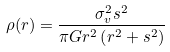Convert formula to latex. <formula><loc_0><loc_0><loc_500><loc_500>\rho ( r ) = \frac { \sigma _ { v } ^ { 2 } s ^ { 2 } } { \pi G r ^ { 2 } \left ( r ^ { 2 } + s ^ { 2 } \right ) }</formula> 